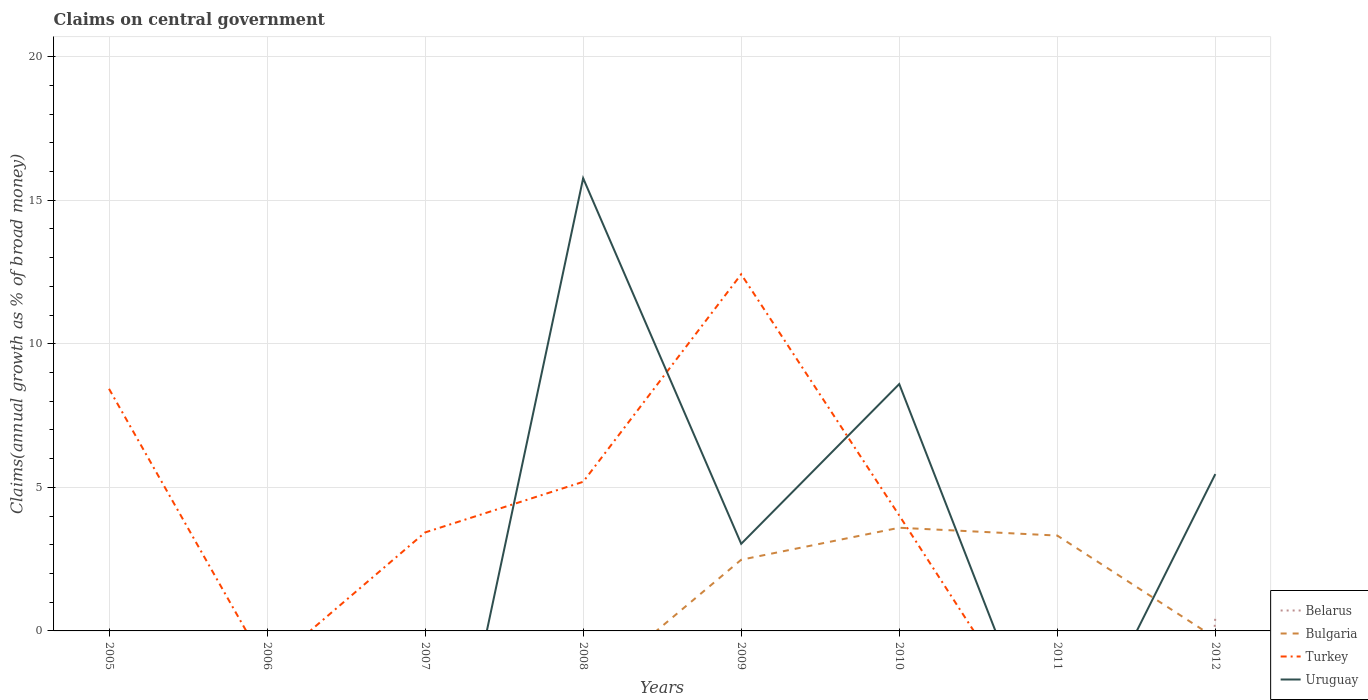Does the line corresponding to Bulgaria intersect with the line corresponding to Uruguay?
Offer a terse response. Yes. Is the number of lines equal to the number of legend labels?
Offer a terse response. No. What is the total percentage of broad money claimed on centeral government in Uruguay in the graph?
Ensure brevity in your answer.  -5.56. What is the difference between the highest and the second highest percentage of broad money claimed on centeral government in Turkey?
Provide a succinct answer. 12.42. What is the difference between the highest and the lowest percentage of broad money claimed on centeral government in Turkey?
Your answer should be very brief. 3. Is the percentage of broad money claimed on centeral government in Turkey strictly greater than the percentage of broad money claimed on centeral government in Bulgaria over the years?
Keep it short and to the point. No. How many lines are there?
Provide a succinct answer. 4. What is the difference between two consecutive major ticks on the Y-axis?
Offer a terse response. 5. Does the graph contain grids?
Offer a terse response. Yes. What is the title of the graph?
Provide a short and direct response. Claims on central government. What is the label or title of the Y-axis?
Ensure brevity in your answer.  Claims(annual growth as % of broad money). What is the Claims(annual growth as % of broad money) in Belarus in 2005?
Your answer should be very brief. 0. What is the Claims(annual growth as % of broad money) of Turkey in 2005?
Give a very brief answer. 8.43. What is the Claims(annual growth as % of broad money) in Belarus in 2006?
Make the answer very short. 0. What is the Claims(annual growth as % of broad money) in Turkey in 2006?
Give a very brief answer. 0. What is the Claims(annual growth as % of broad money) in Uruguay in 2006?
Provide a succinct answer. 0. What is the Claims(annual growth as % of broad money) in Belarus in 2007?
Make the answer very short. 0. What is the Claims(annual growth as % of broad money) of Turkey in 2007?
Your response must be concise. 3.43. What is the Claims(annual growth as % of broad money) of Uruguay in 2007?
Your answer should be very brief. 0. What is the Claims(annual growth as % of broad money) in Bulgaria in 2008?
Your answer should be compact. 0. What is the Claims(annual growth as % of broad money) of Turkey in 2008?
Offer a very short reply. 5.19. What is the Claims(annual growth as % of broad money) of Uruguay in 2008?
Offer a very short reply. 15.77. What is the Claims(annual growth as % of broad money) in Belarus in 2009?
Keep it short and to the point. 0. What is the Claims(annual growth as % of broad money) of Bulgaria in 2009?
Provide a short and direct response. 2.48. What is the Claims(annual growth as % of broad money) of Turkey in 2009?
Provide a short and direct response. 12.42. What is the Claims(annual growth as % of broad money) in Uruguay in 2009?
Your answer should be compact. 3.03. What is the Claims(annual growth as % of broad money) in Bulgaria in 2010?
Make the answer very short. 3.59. What is the Claims(annual growth as % of broad money) in Turkey in 2010?
Make the answer very short. 4.02. What is the Claims(annual growth as % of broad money) in Uruguay in 2010?
Offer a very short reply. 8.6. What is the Claims(annual growth as % of broad money) in Bulgaria in 2011?
Ensure brevity in your answer.  3.32. What is the Claims(annual growth as % of broad money) in Uruguay in 2011?
Your response must be concise. 0. What is the Claims(annual growth as % of broad money) of Belarus in 2012?
Your response must be concise. 0.49. What is the Claims(annual growth as % of broad money) of Bulgaria in 2012?
Make the answer very short. 0. What is the Claims(annual growth as % of broad money) of Uruguay in 2012?
Offer a terse response. 5.46. Across all years, what is the maximum Claims(annual growth as % of broad money) in Belarus?
Your answer should be compact. 0.49. Across all years, what is the maximum Claims(annual growth as % of broad money) of Bulgaria?
Provide a short and direct response. 3.59. Across all years, what is the maximum Claims(annual growth as % of broad money) in Turkey?
Make the answer very short. 12.42. Across all years, what is the maximum Claims(annual growth as % of broad money) of Uruguay?
Your answer should be compact. 15.77. Across all years, what is the minimum Claims(annual growth as % of broad money) in Bulgaria?
Provide a succinct answer. 0. Across all years, what is the minimum Claims(annual growth as % of broad money) of Turkey?
Offer a terse response. 0. What is the total Claims(annual growth as % of broad money) in Belarus in the graph?
Your response must be concise. 0.49. What is the total Claims(annual growth as % of broad money) in Bulgaria in the graph?
Your answer should be compact. 9.39. What is the total Claims(annual growth as % of broad money) of Turkey in the graph?
Ensure brevity in your answer.  33.5. What is the total Claims(annual growth as % of broad money) in Uruguay in the graph?
Offer a very short reply. 32.86. What is the difference between the Claims(annual growth as % of broad money) of Turkey in 2005 and that in 2007?
Offer a terse response. 5. What is the difference between the Claims(annual growth as % of broad money) of Turkey in 2005 and that in 2008?
Ensure brevity in your answer.  3.24. What is the difference between the Claims(annual growth as % of broad money) in Turkey in 2005 and that in 2009?
Ensure brevity in your answer.  -3.99. What is the difference between the Claims(annual growth as % of broad money) of Turkey in 2005 and that in 2010?
Offer a very short reply. 4.41. What is the difference between the Claims(annual growth as % of broad money) in Turkey in 2007 and that in 2008?
Offer a very short reply. -1.76. What is the difference between the Claims(annual growth as % of broad money) in Turkey in 2007 and that in 2009?
Keep it short and to the point. -8.99. What is the difference between the Claims(annual growth as % of broad money) in Turkey in 2007 and that in 2010?
Give a very brief answer. -0.59. What is the difference between the Claims(annual growth as % of broad money) of Turkey in 2008 and that in 2009?
Provide a succinct answer. -7.23. What is the difference between the Claims(annual growth as % of broad money) of Uruguay in 2008 and that in 2009?
Ensure brevity in your answer.  12.73. What is the difference between the Claims(annual growth as % of broad money) of Turkey in 2008 and that in 2010?
Your answer should be very brief. 1.17. What is the difference between the Claims(annual growth as % of broad money) in Uruguay in 2008 and that in 2010?
Provide a succinct answer. 7.17. What is the difference between the Claims(annual growth as % of broad money) of Uruguay in 2008 and that in 2012?
Offer a very short reply. 10.3. What is the difference between the Claims(annual growth as % of broad money) in Bulgaria in 2009 and that in 2010?
Provide a succinct answer. -1.11. What is the difference between the Claims(annual growth as % of broad money) in Turkey in 2009 and that in 2010?
Offer a terse response. 8.4. What is the difference between the Claims(annual growth as % of broad money) of Uruguay in 2009 and that in 2010?
Your answer should be compact. -5.56. What is the difference between the Claims(annual growth as % of broad money) of Bulgaria in 2009 and that in 2011?
Make the answer very short. -0.84. What is the difference between the Claims(annual growth as % of broad money) in Uruguay in 2009 and that in 2012?
Your answer should be compact. -2.43. What is the difference between the Claims(annual growth as % of broad money) in Bulgaria in 2010 and that in 2011?
Offer a terse response. 0.27. What is the difference between the Claims(annual growth as % of broad money) in Uruguay in 2010 and that in 2012?
Ensure brevity in your answer.  3.14. What is the difference between the Claims(annual growth as % of broad money) of Turkey in 2005 and the Claims(annual growth as % of broad money) of Uruguay in 2008?
Keep it short and to the point. -7.33. What is the difference between the Claims(annual growth as % of broad money) of Turkey in 2005 and the Claims(annual growth as % of broad money) of Uruguay in 2009?
Keep it short and to the point. 5.4. What is the difference between the Claims(annual growth as % of broad money) of Turkey in 2005 and the Claims(annual growth as % of broad money) of Uruguay in 2010?
Your answer should be compact. -0.17. What is the difference between the Claims(annual growth as % of broad money) in Turkey in 2005 and the Claims(annual growth as % of broad money) in Uruguay in 2012?
Provide a short and direct response. 2.97. What is the difference between the Claims(annual growth as % of broad money) of Turkey in 2007 and the Claims(annual growth as % of broad money) of Uruguay in 2008?
Provide a short and direct response. -12.34. What is the difference between the Claims(annual growth as % of broad money) of Turkey in 2007 and the Claims(annual growth as % of broad money) of Uruguay in 2009?
Ensure brevity in your answer.  0.4. What is the difference between the Claims(annual growth as % of broad money) in Turkey in 2007 and the Claims(annual growth as % of broad money) in Uruguay in 2010?
Provide a succinct answer. -5.17. What is the difference between the Claims(annual growth as % of broad money) of Turkey in 2007 and the Claims(annual growth as % of broad money) of Uruguay in 2012?
Give a very brief answer. -2.03. What is the difference between the Claims(annual growth as % of broad money) in Turkey in 2008 and the Claims(annual growth as % of broad money) in Uruguay in 2009?
Your answer should be compact. 2.16. What is the difference between the Claims(annual growth as % of broad money) in Turkey in 2008 and the Claims(annual growth as % of broad money) in Uruguay in 2010?
Keep it short and to the point. -3.4. What is the difference between the Claims(annual growth as % of broad money) in Turkey in 2008 and the Claims(annual growth as % of broad money) in Uruguay in 2012?
Make the answer very short. -0.27. What is the difference between the Claims(annual growth as % of broad money) of Bulgaria in 2009 and the Claims(annual growth as % of broad money) of Turkey in 2010?
Offer a very short reply. -1.54. What is the difference between the Claims(annual growth as % of broad money) in Bulgaria in 2009 and the Claims(annual growth as % of broad money) in Uruguay in 2010?
Provide a succinct answer. -6.12. What is the difference between the Claims(annual growth as % of broad money) in Turkey in 2009 and the Claims(annual growth as % of broad money) in Uruguay in 2010?
Provide a short and direct response. 3.82. What is the difference between the Claims(annual growth as % of broad money) in Bulgaria in 2009 and the Claims(annual growth as % of broad money) in Uruguay in 2012?
Keep it short and to the point. -2.98. What is the difference between the Claims(annual growth as % of broad money) in Turkey in 2009 and the Claims(annual growth as % of broad money) in Uruguay in 2012?
Your response must be concise. 6.96. What is the difference between the Claims(annual growth as % of broad money) in Bulgaria in 2010 and the Claims(annual growth as % of broad money) in Uruguay in 2012?
Offer a terse response. -1.87. What is the difference between the Claims(annual growth as % of broad money) of Turkey in 2010 and the Claims(annual growth as % of broad money) of Uruguay in 2012?
Make the answer very short. -1.44. What is the difference between the Claims(annual growth as % of broad money) of Bulgaria in 2011 and the Claims(annual growth as % of broad money) of Uruguay in 2012?
Your answer should be very brief. -2.14. What is the average Claims(annual growth as % of broad money) of Belarus per year?
Provide a succinct answer. 0.06. What is the average Claims(annual growth as % of broad money) in Bulgaria per year?
Keep it short and to the point. 1.17. What is the average Claims(annual growth as % of broad money) in Turkey per year?
Your answer should be very brief. 4.19. What is the average Claims(annual growth as % of broad money) in Uruguay per year?
Make the answer very short. 4.11. In the year 2008, what is the difference between the Claims(annual growth as % of broad money) of Turkey and Claims(annual growth as % of broad money) of Uruguay?
Your answer should be very brief. -10.57. In the year 2009, what is the difference between the Claims(annual growth as % of broad money) of Bulgaria and Claims(annual growth as % of broad money) of Turkey?
Give a very brief answer. -9.94. In the year 2009, what is the difference between the Claims(annual growth as % of broad money) in Bulgaria and Claims(annual growth as % of broad money) in Uruguay?
Ensure brevity in your answer.  -0.56. In the year 2009, what is the difference between the Claims(annual growth as % of broad money) of Turkey and Claims(annual growth as % of broad money) of Uruguay?
Ensure brevity in your answer.  9.39. In the year 2010, what is the difference between the Claims(annual growth as % of broad money) of Bulgaria and Claims(annual growth as % of broad money) of Turkey?
Keep it short and to the point. -0.43. In the year 2010, what is the difference between the Claims(annual growth as % of broad money) in Bulgaria and Claims(annual growth as % of broad money) in Uruguay?
Offer a very short reply. -5. In the year 2010, what is the difference between the Claims(annual growth as % of broad money) in Turkey and Claims(annual growth as % of broad money) in Uruguay?
Ensure brevity in your answer.  -4.58. In the year 2012, what is the difference between the Claims(annual growth as % of broad money) of Belarus and Claims(annual growth as % of broad money) of Uruguay?
Ensure brevity in your answer.  -4.97. What is the ratio of the Claims(annual growth as % of broad money) in Turkey in 2005 to that in 2007?
Keep it short and to the point. 2.46. What is the ratio of the Claims(annual growth as % of broad money) in Turkey in 2005 to that in 2008?
Provide a short and direct response. 1.62. What is the ratio of the Claims(annual growth as % of broad money) in Turkey in 2005 to that in 2009?
Make the answer very short. 0.68. What is the ratio of the Claims(annual growth as % of broad money) in Turkey in 2005 to that in 2010?
Keep it short and to the point. 2.1. What is the ratio of the Claims(annual growth as % of broad money) in Turkey in 2007 to that in 2008?
Ensure brevity in your answer.  0.66. What is the ratio of the Claims(annual growth as % of broad money) of Turkey in 2007 to that in 2009?
Keep it short and to the point. 0.28. What is the ratio of the Claims(annual growth as % of broad money) in Turkey in 2007 to that in 2010?
Your response must be concise. 0.85. What is the ratio of the Claims(annual growth as % of broad money) in Turkey in 2008 to that in 2009?
Provide a short and direct response. 0.42. What is the ratio of the Claims(annual growth as % of broad money) of Uruguay in 2008 to that in 2009?
Make the answer very short. 5.2. What is the ratio of the Claims(annual growth as % of broad money) of Turkey in 2008 to that in 2010?
Provide a succinct answer. 1.29. What is the ratio of the Claims(annual growth as % of broad money) in Uruguay in 2008 to that in 2010?
Keep it short and to the point. 1.83. What is the ratio of the Claims(annual growth as % of broad money) in Uruguay in 2008 to that in 2012?
Your response must be concise. 2.89. What is the ratio of the Claims(annual growth as % of broad money) of Bulgaria in 2009 to that in 2010?
Provide a succinct answer. 0.69. What is the ratio of the Claims(annual growth as % of broad money) in Turkey in 2009 to that in 2010?
Your answer should be very brief. 3.09. What is the ratio of the Claims(annual growth as % of broad money) of Uruguay in 2009 to that in 2010?
Make the answer very short. 0.35. What is the ratio of the Claims(annual growth as % of broad money) of Bulgaria in 2009 to that in 2011?
Give a very brief answer. 0.75. What is the ratio of the Claims(annual growth as % of broad money) of Uruguay in 2009 to that in 2012?
Ensure brevity in your answer.  0.56. What is the ratio of the Claims(annual growth as % of broad money) of Bulgaria in 2010 to that in 2011?
Your answer should be very brief. 1.08. What is the ratio of the Claims(annual growth as % of broad money) in Uruguay in 2010 to that in 2012?
Make the answer very short. 1.57. What is the difference between the highest and the second highest Claims(annual growth as % of broad money) of Bulgaria?
Your response must be concise. 0.27. What is the difference between the highest and the second highest Claims(annual growth as % of broad money) in Turkey?
Make the answer very short. 3.99. What is the difference between the highest and the second highest Claims(annual growth as % of broad money) of Uruguay?
Make the answer very short. 7.17. What is the difference between the highest and the lowest Claims(annual growth as % of broad money) of Belarus?
Provide a succinct answer. 0.49. What is the difference between the highest and the lowest Claims(annual growth as % of broad money) in Bulgaria?
Your answer should be very brief. 3.59. What is the difference between the highest and the lowest Claims(annual growth as % of broad money) of Turkey?
Your answer should be compact. 12.42. What is the difference between the highest and the lowest Claims(annual growth as % of broad money) of Uruguay?
Ensure brevity in your answer.  15.77. 